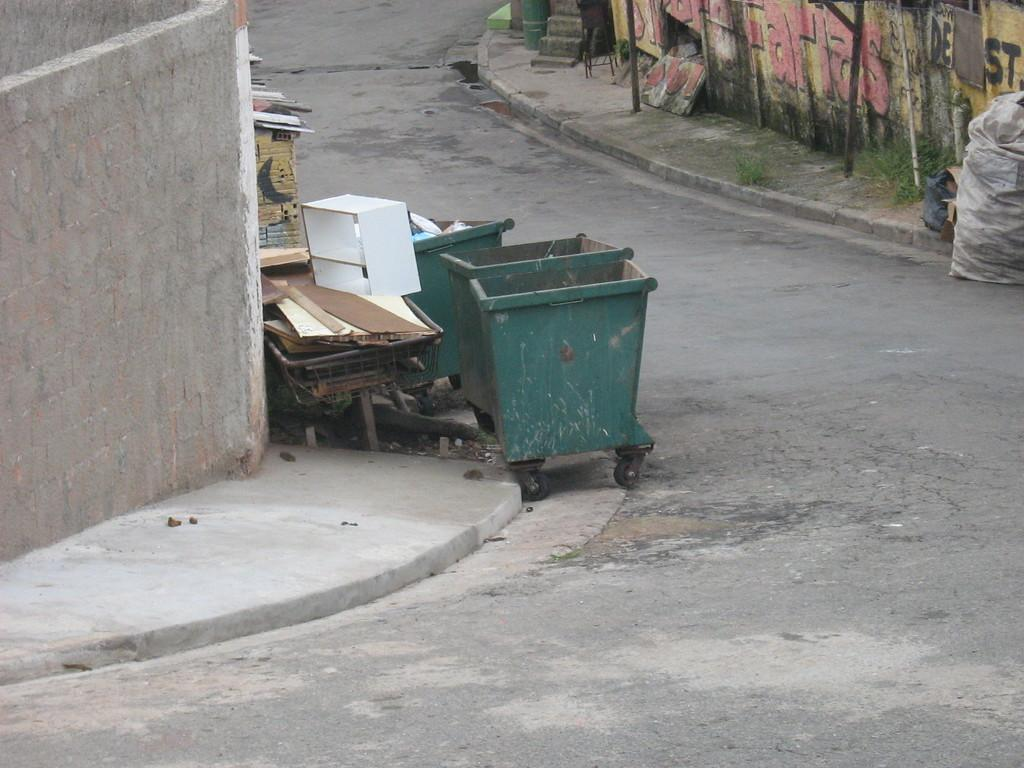What is the main feature of the image? There is a road in the image. What can be seen traveling along the road? There are trolleys in the image. What structure is present in the image? There is a stand in the image. What type of objects are visible on the ground? There are wooden blocks and a gunny bag in the image. What else can be seen in the image? There are rods and walls in the image. How many apples are hanging from the rods in the image? There are no apples present in the image; only wooden blocks, a gunny bag, and rods can be seen. What type of birds can be seen flying near the walls in the image? There are no birds present in the image; only trolleys, a stand, wooden blocks, a gunny bag, rods, and walls can be seen. 